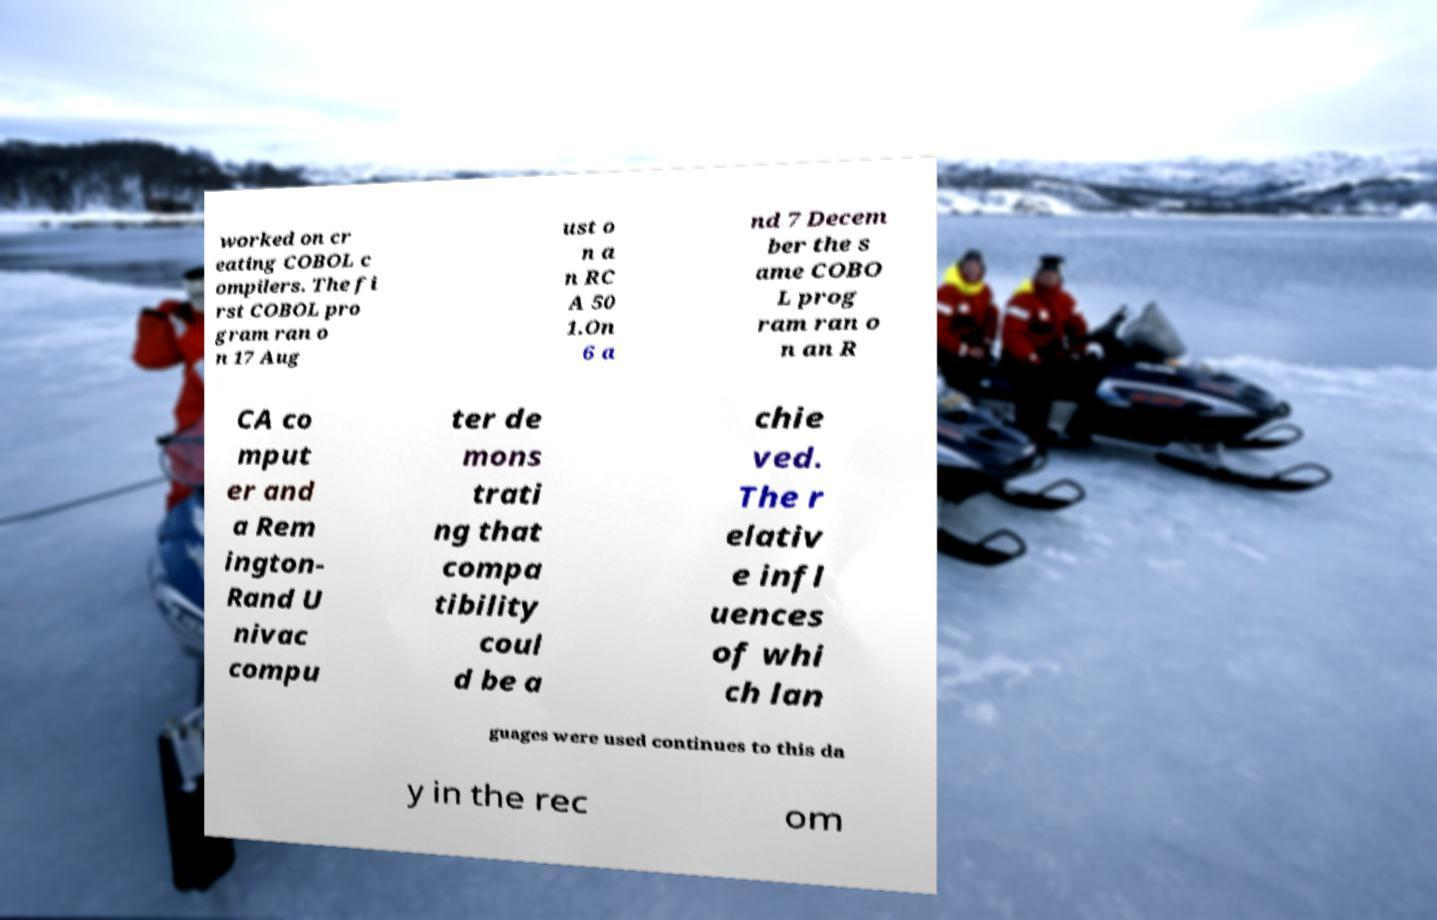Can you accurately transcribe the text from the provided image for me? worked on cr eating COBOL c ompilers. The fi rst COBOL pro gram ran o n 17 Aug ust o n a n RC A 50 1.On 6 a nd 7 Decem ber the s ame COBO L prog ram ran o n an R CA co mput er and a Rem ington- Rand U nivac compu ter de mons trati ng that compa tibility coul d be a chie ved. The r elativ e infl uences of whi ch lan guages were used continues to this da y in the rec om 